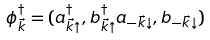<formula> <loc_0><loc_0><loc_500><loc_500>\phi _ { \vec { k } } ^ { \dagger } = ( a _ { \vec { k } \uparrow } ^ { \dagger } , b _ { \vec { k } \uparrow } ^ { \dagger } a _ { - \vec { k } \downarrow } , b _ { - \vec { k } \downarrow } )</formula> 